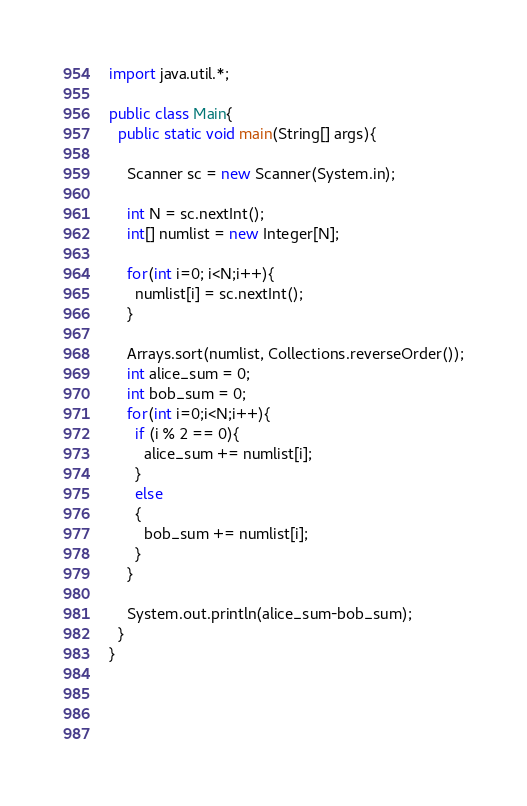<code> <loc_0><loc_0><loc_500><loc_500><_Java_>import java.util.*;

public class Main{
  public static void main(String[] args){
    
    Scanner sc = new Scanner(System.in);
    
    int N = sc.nextInt();
    int[] numlist = new Integer[N];
    
    for(int i=0; i<N;i++){
      numlist[i] = sc.nextInt();
    }
    
    Arrays.sort(numlist, Collections.reverseOrder());
    int alice_sum = 0;
    int bob_sum = 0;
    for(int i=0;i<N;i++){
      if (i % 2 == 0){
        alice_sum += numlist[i];
      }
      else
      {
        bob_sum += numlist[i];
      }
    }
    
    System.out.println(alice_sum-bob_sum);
  }
}

      
      
  </code> 